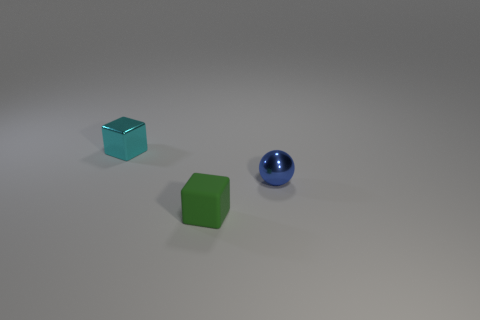Add 3 yellow metallic cylinders. How many objects exist? 6 Subtract all cubes. How many objects are left? 1 Subtract 1 green cubes. How many objects are left? 2 Subtract all big gray metallic cylinders. Subtract all metallic things. How many objects are left? 1 Add 1 tiny spheres. How many tiny spheres are left? 2 Add 3 small green matte cubes. How many small green matte cubes exist? 4 